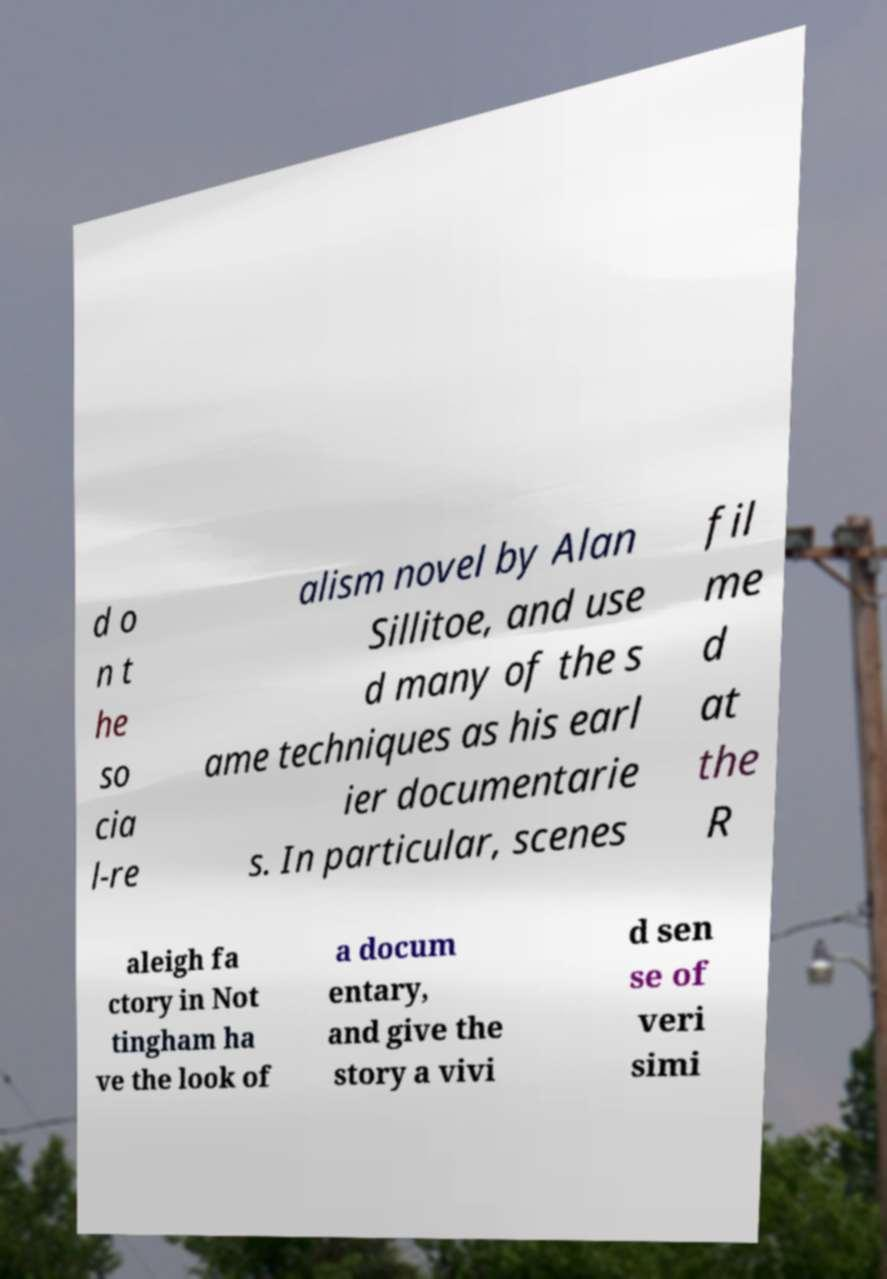I need the written content from this picture converted into text. Can you do that? d o n t he so cia l-re alism novel by Alan Sillitoe, and use d many of the s ame techniques as his earl ier documentarie s. In particular, scenes fil me d at the R aleigh fa ctory in Not tingham ha ve the look of a docum entary, and give the story a vivi d sen se of veri simi 